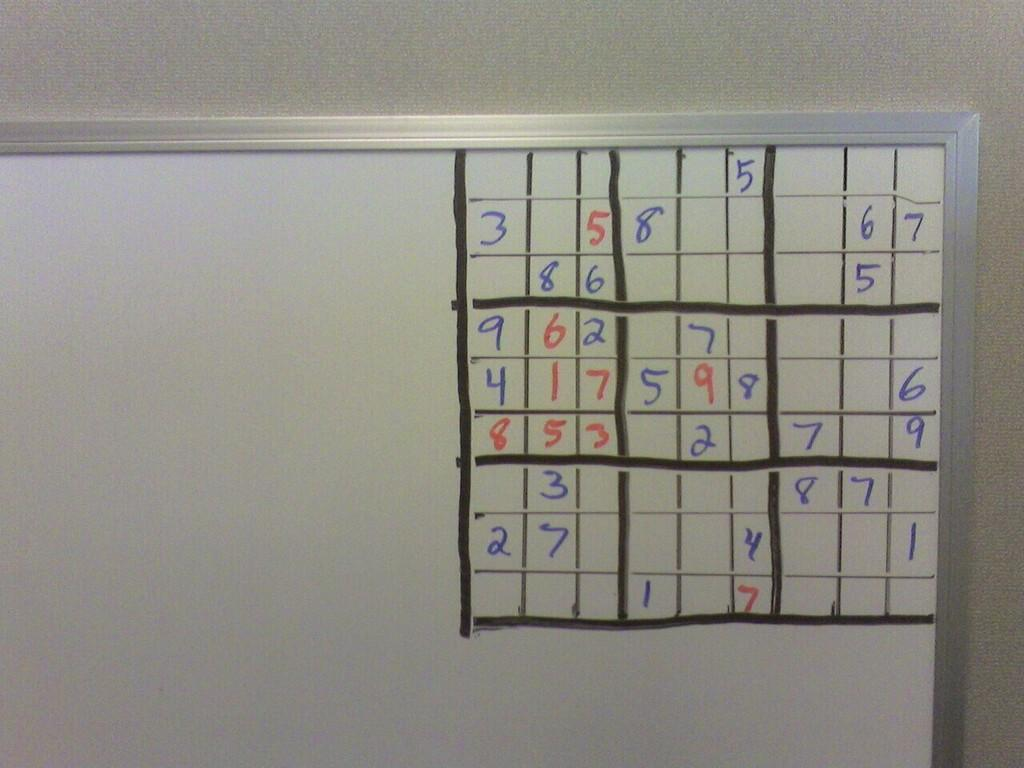<image>
Share a concise interpretation of the image provided. The corner of a whiteboard playing soduko and number 5 on the top row 